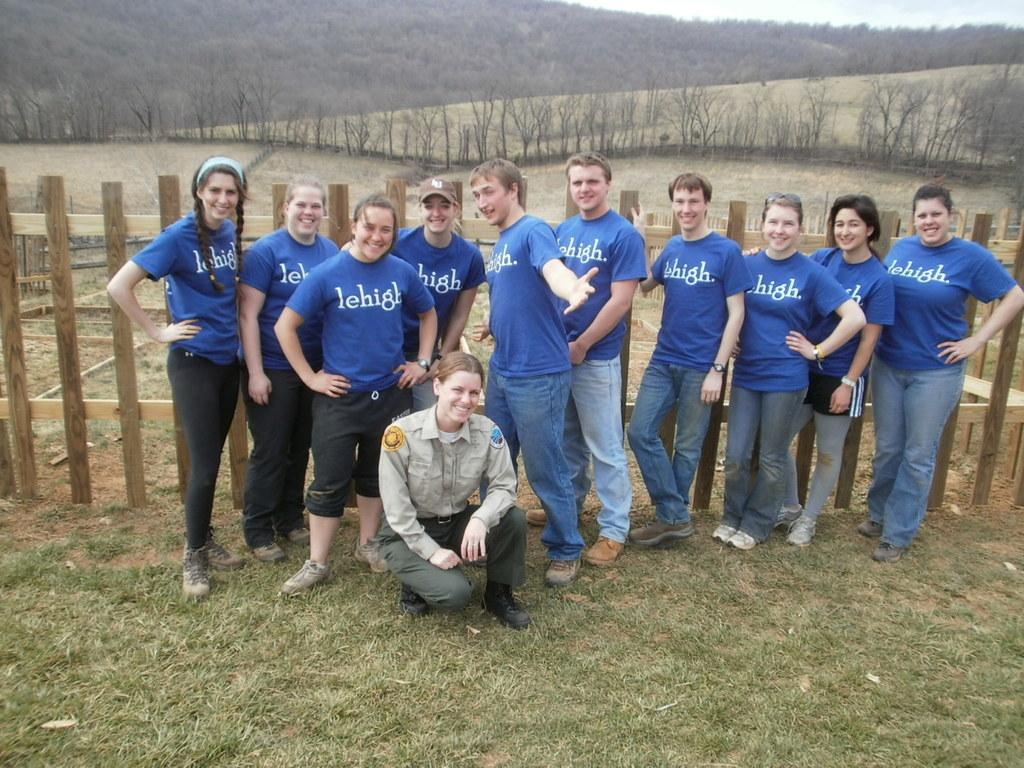What are the people in the image doing? The people in the image are posing for a photo. What is located behind the people in the image? There is a wooden fence behind the people. What can be seen in the background of the image? There are trees and mountains in the background of the image. What type of memory is stored in the pot in the image? There is no pot present in the image, so it is not possible to determine if any memory is stored in a pot. 